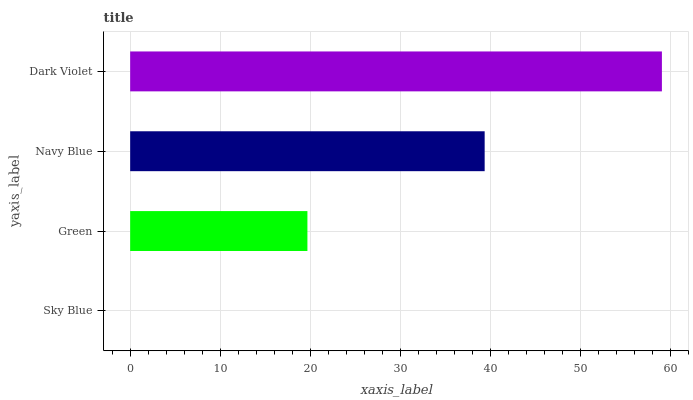Is Sky Blue the minimum?
Answer yes or no. Yes. Is Dark Violet the maximum?
Answer yes or no. Yes. Is Green the minimum?
Answer yes or no. No. Is Green the maximum?
Answer yes or no. No. Is Green greater than Sky Blue?
Answer yes or no. Yes. Is Sky Blue less than Green?
Answer yes or no. Yes. Is Sky Blue greater than Green?
Answer yes or no. No. Is Green less than Sky Blue?
Answer yes or no. No. Is Navy Blue the high median?
Answer yes or no. Yes. Is Green the low median?
Answer yes or no. Yes. Is Sky Blue the high median?
Answer yes or no. No. Is Sky Blue the low median?
Answer yes or no. No. 